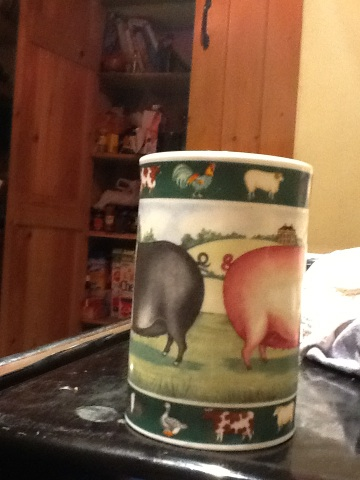Imagine the cup is magical. What powers does it have? If this cup were magical, it might have the power to summon the animals depicted on it. Imagine placing it on a table and reciting a spell, and suddenly, a friendly pink pig and a curious black pig appear to keep you company. Perhaps it could also transport you to a whimsical farm setting whenever you drink from it, allowing you to experience the serene and peaceful life of the countryside for a while. 